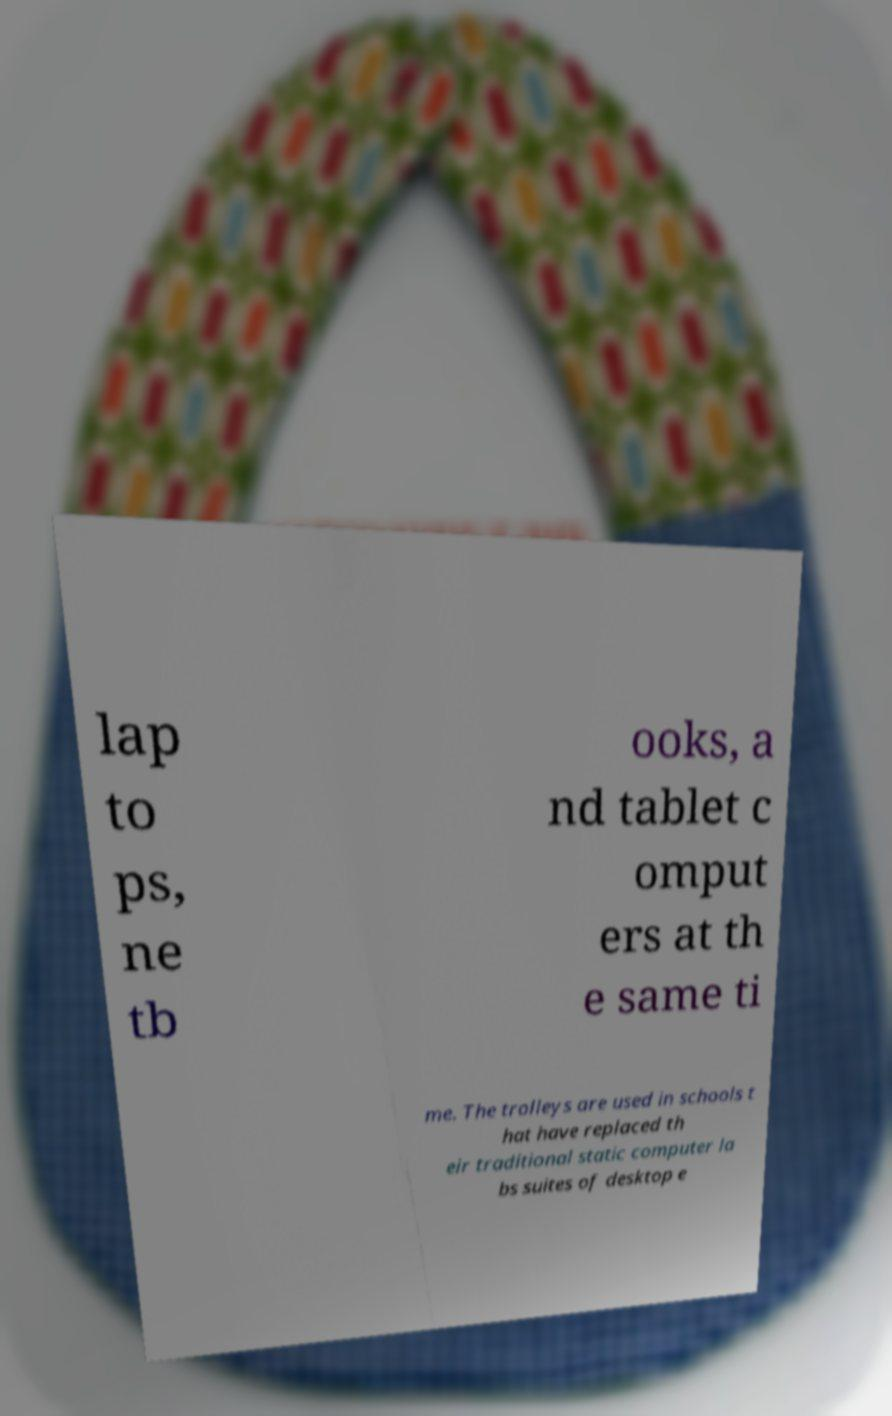Could you extract and type out the text from this image? lap to ps, ne tb ooks, a nd tablet c omput ers at th e same ti me. The trolleys are used in schools t hat have replaced th eir traditional static computer la bs suites of desktop e 